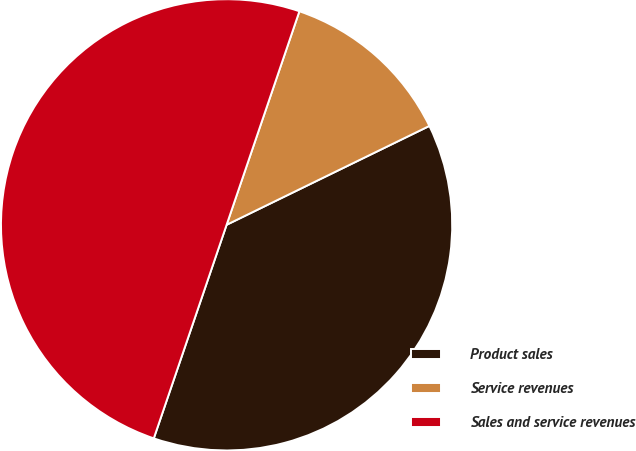<chart> <loc_0><loc_0><loc_500><loc_500><pie_chart><fcel>Product sales<fcel>Service revenues<fcel>Sales and service revenues<nl><fcel>37.45%<fcel>12.55%<fcel>50.0%<nl></chart> 